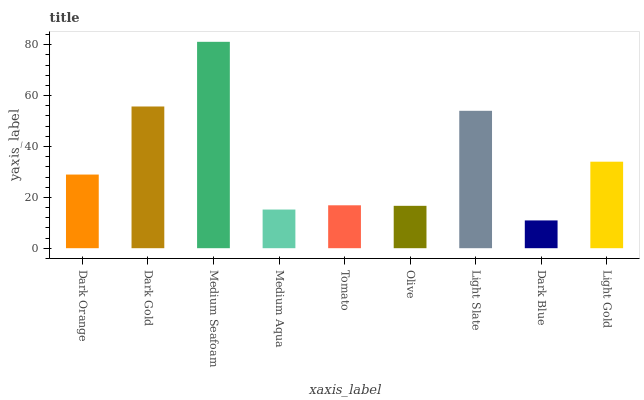Is Dark Blue the minimum?
Answer yes or no. Yes. Is Medium Seafoam the maximum?
Answer yes or no. Yes. Is Dark Gold the minimum?
Answer yes or no. No. Is Dark Gold the maximum?
Answer yes or no. No. Is Dark Gold greater than Dark Orange?
Answer yes or no. Yes. Is Dark Orange less than Dark Gold?
Answer yes or no. Yes. Is Dark Orange greater than Dark Gold?
Answer yes or no. No. Is Dark Gold less than Dark Orange?
Answer yes or no. No. Is Dark Orange the high median?
Answer yes or no. Yes. Is Dark Orange the low median?
Answer yes or no. Yes. Is Light Gold the high median?
Answer yes or no. No. Is Dark Gold the low median?
Answer yes or no. No. 